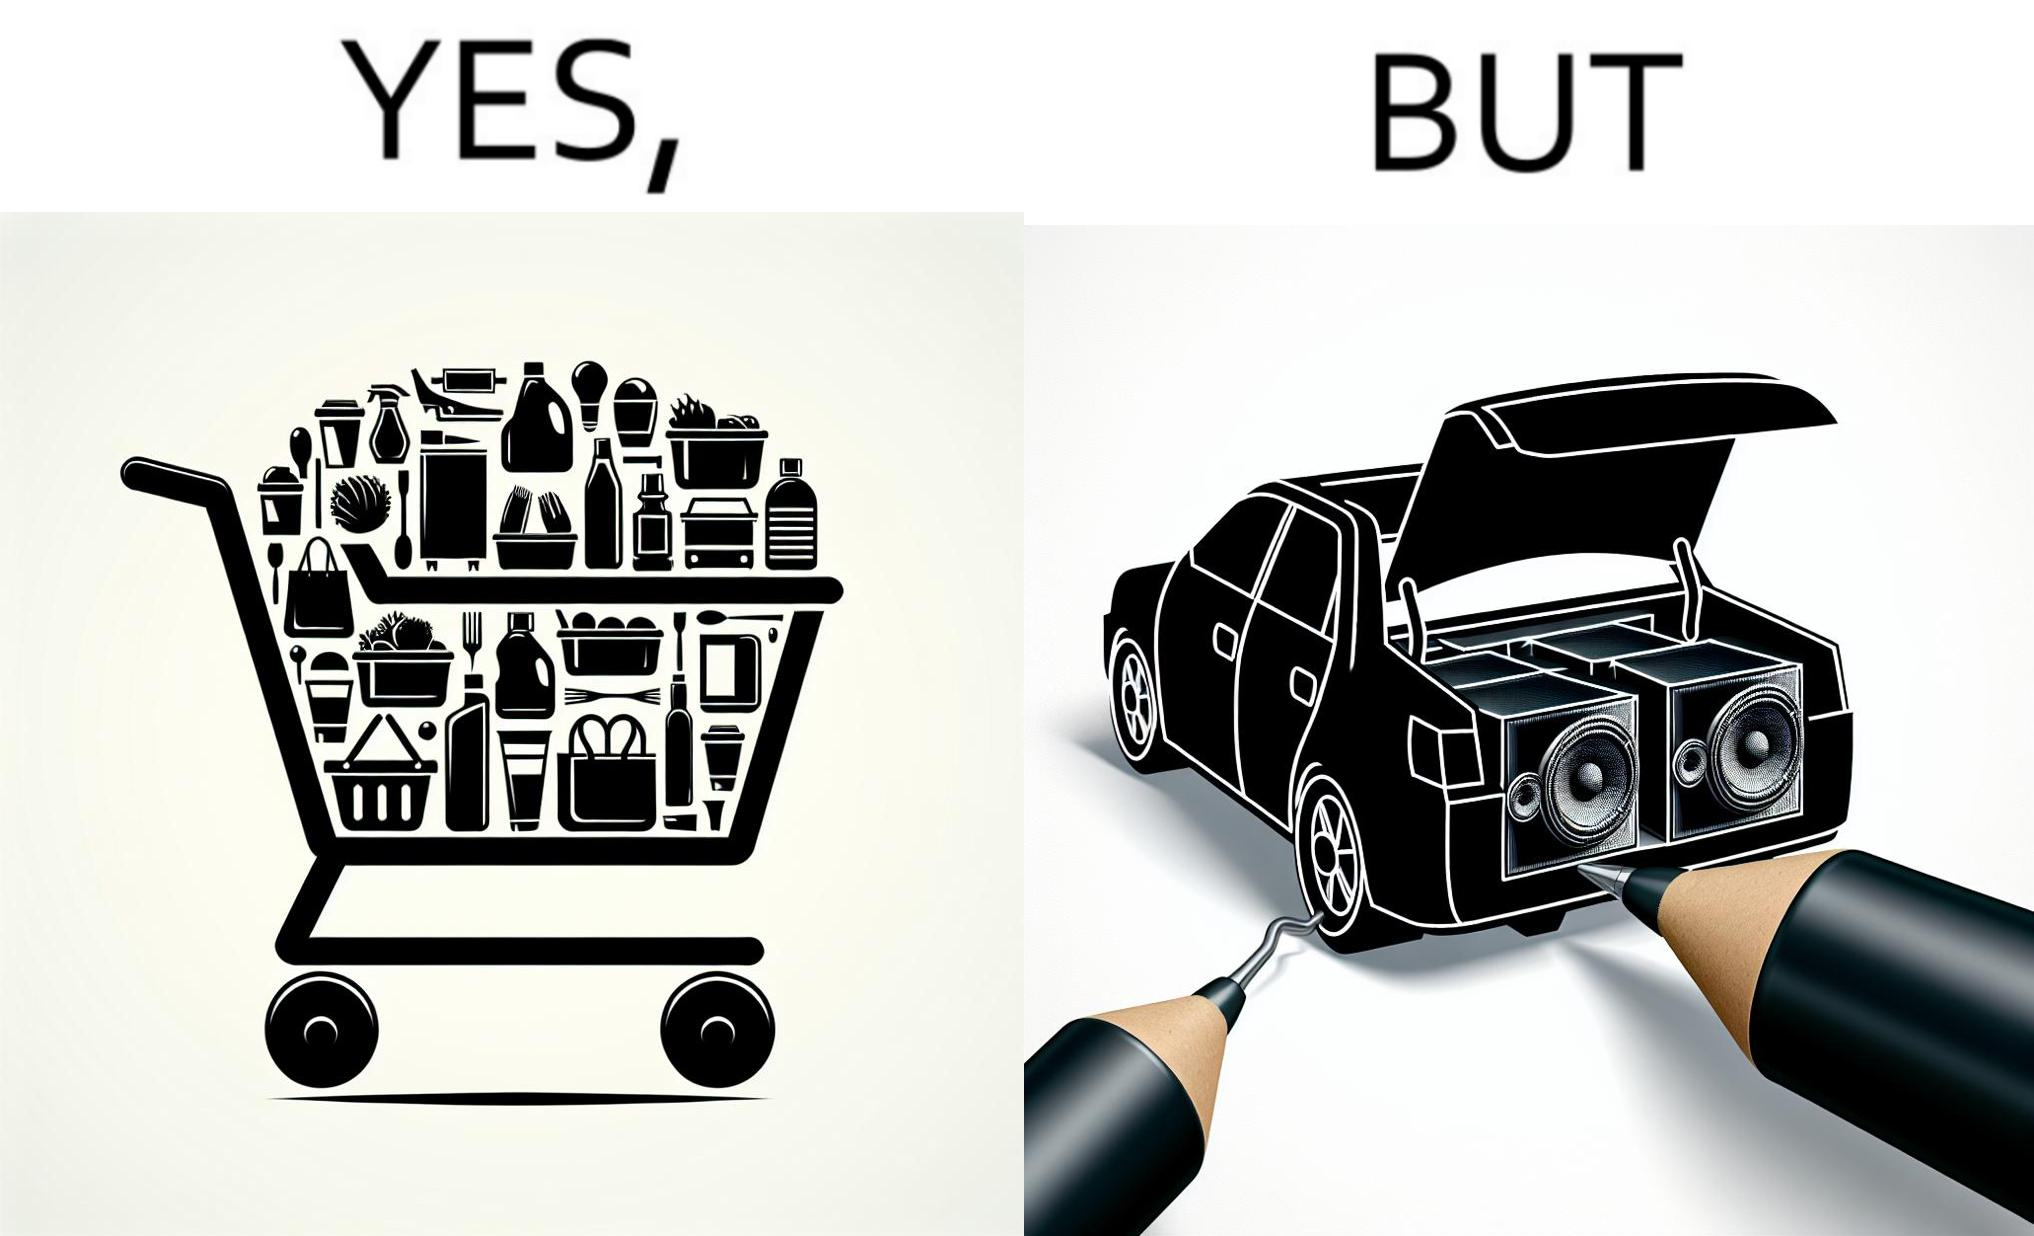Compare the left and right sides of this image. In the left part of the image: a shopping cart full of items In the right part of the image: a black car with its trunk lid open and some boxes, probably speakers, kept in the trunk 